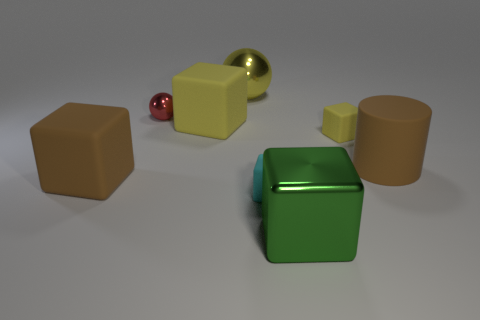How many other things are there of the same material as the red ball?
Give a very brief answer. 2. There is a large rubber thing that is to the left of the small red metal thing behind the big block that is to the left of the red metal object; what color is it?
Provide a succinct answer. Brown. There is a yellow block that is the same size as the yellow metal sphere; what is it made of?
Provide a short and direct response. Rubber. How many objects are either big rubber things in front of the large yellow block or shiny spheres?
Your answer should be very brief. 4. Is there a large blue thing?
Make the answer very short. No. What is the sphere that is behind the tiny red sphere made of?
Your response must be concise. Metal. There is a block that is the same color as the cylinder; what material is it?
Offer a very short reply. Rubber. How many large things are either green metallic objects or cubes?
Give a very brief answer. 3. The small metallic thing has what color?
Offer a very short reply. Red. There is a large block that is behind the big brown matte cylinder; are there any big brown matte objects that are to the right of it?
Your answer should be very brief. Yes. 